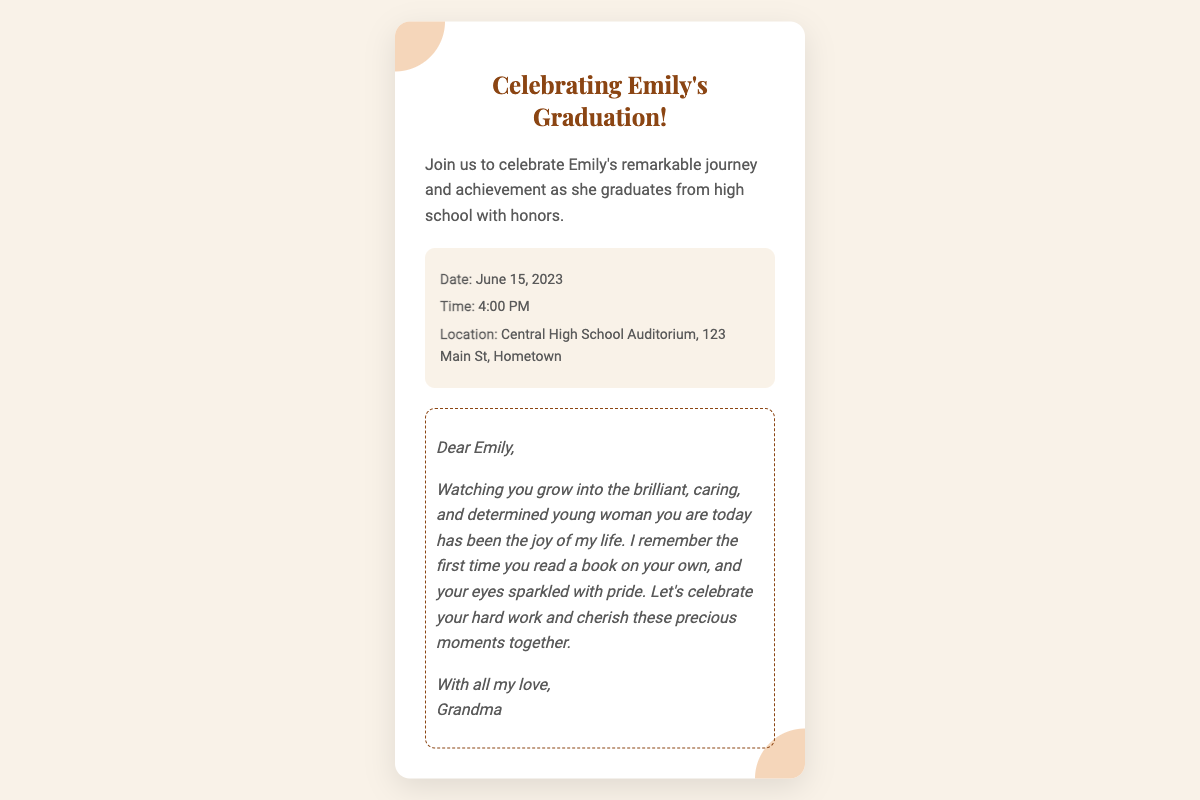What is the occasion being celebrated? The occasion being celebrated is Emily's graduation from high school with honors.
Answer: Emily's graduation What is the date of the event? The date of the event is specified in the document as June 15, 2023.
Answer: June 15, 2023 What time does the celebration start? The time of the celebration is mentioned in the document, which is at 4:00 PM.
Answer: 4:00 PM Where is the location of the event? The location is detailed in the document as Central High School Auditorium, 123 Main St, Hometown.
Answer: Central High School Auditorium, 123 Main St, Hometown Who is the personal note addressed to? The personal note in the document is directed towards Emily, as indicated at the beginning of the note.
Answer: Emily What quality of Emily is highlighted by Grandma in her note? In her note, Grandma highlights Emily's brilliance, care, and determination as qualities she admires.
Answer: Brilliant, caring, determined What significant moment does Grandma recall in her note? Grandma recalls the moment when Emily first read a book on her own, which is mentioned in the personal note.
Answer: First time reading a book What is the document's overall design style aimed to convey? The overall design style, including colors and fonts, is aimed at conveying a warm and intimate celebration atmosphere.
Answer: Warm and intimate What format does this document represent? This document represents an invitation or ticket format specifically created for the event.
Answer: Ticket 